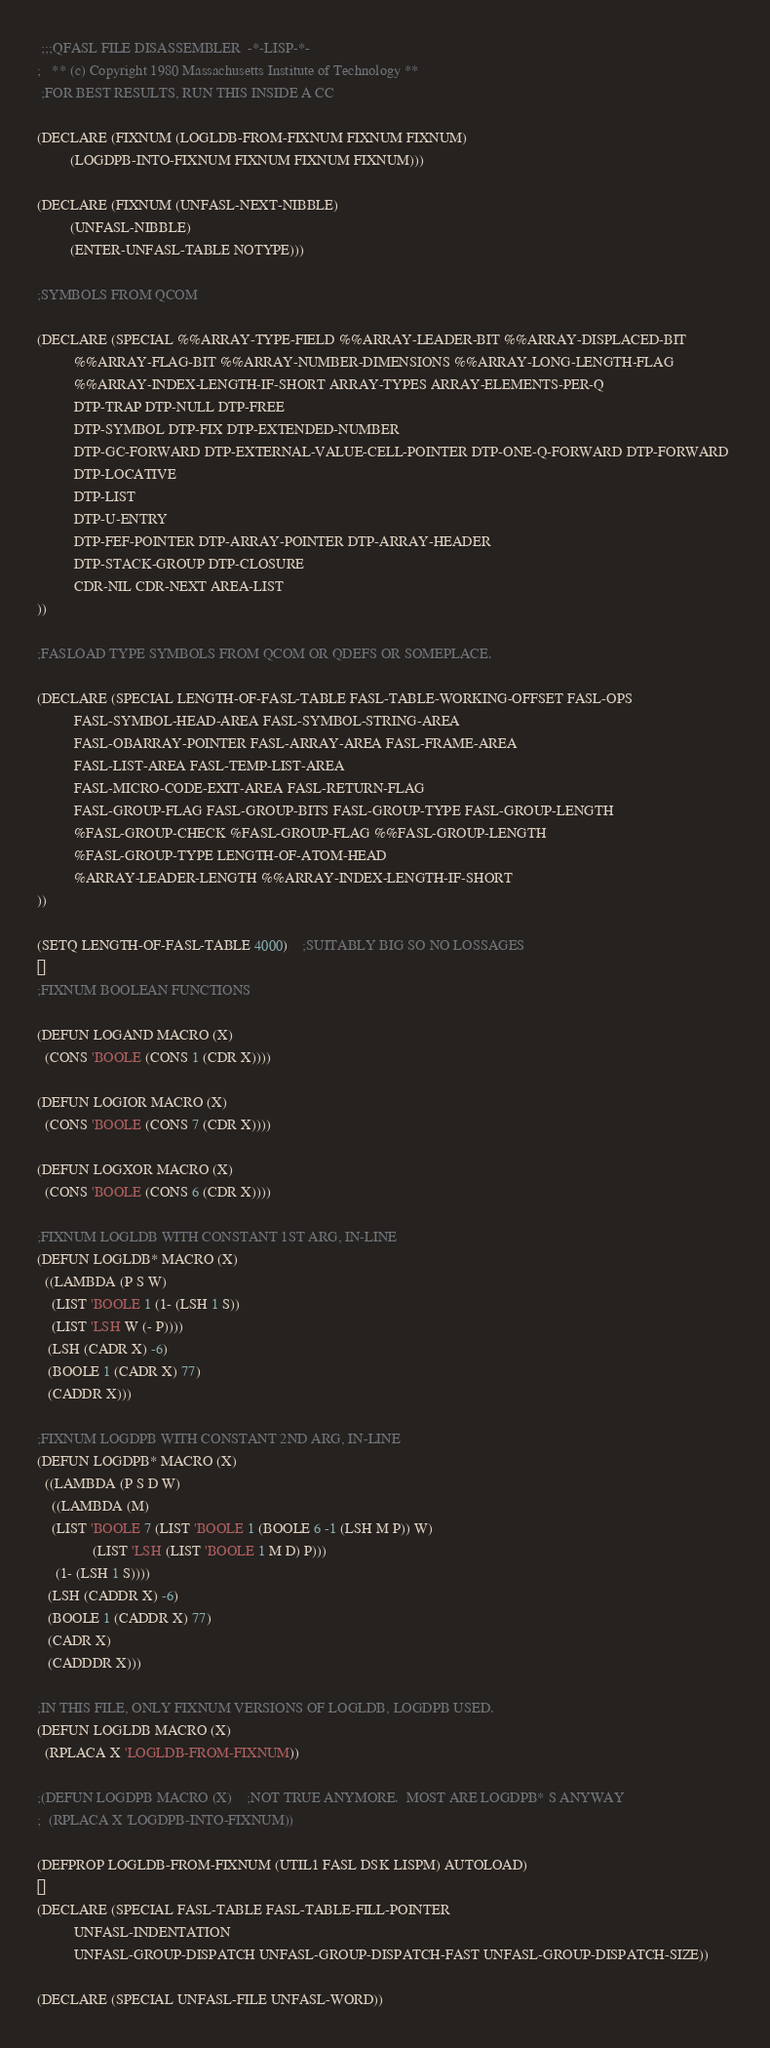<code> <loc_0><loc_0><loc_500><loc_500><_Lisp_> ;;;QFASL FILE DISASSEMBLER  -*-LISP-*-
;	** (c) Copyright 1980 Massachusetts Institute of Technology **
 ;FOR BEST RESULTS, RUN THIS INSIDE A CC

(DECLARE (FIXNUM (LOGLDB-FROM-FIXNUM FIXNUM FIXNUM)
		 (LOGDPB-INTO-FIXNUM FIXNUM FIXNUM FIXNUM)))

(DECLARE (FIXNUM (UNFASL-NEXT-NIBBLE)
		 (UNFASL-NIBBLE)
		 (ENTER-UNFASL-TABLE NOTYPE)))

;SYMBOLS FROM QCOM

(DECLARE (SPECIAL %%ARRAY-TYPE-FIELD %%ARRAY-LEADER-BIT %%ARRAY-DISPLACED-BIT
		  %%ARRAY-FLAG-BIT %%ARRAY-NUMBER-DIMENSIONS %%ARRAY-LONG-LENGTH-FLAG
		  %%ARRAY-INDEX-LENGTH-IF-SHORT ARRAY-TYPES ARRAY-ELEMENTS-PER-Q
		  DTP-TRAP DTP-NULL DTP-FREE 
		  DTP-SYMBOL DTP-FIX DTP-EXTENDED-NUMBER 
		  DTP-GC-FORWARD DTP-EXTERNAL-VALUE-CELL-POINTER DTP-ONE-Q-FORWARD DTP-FORWARD 
		  DTP-LOCATIVE  
		  DTP-LIST  
		  DTP-U-ENTRY  
		  DTP-FEF-POINTER DTP-ARRAY-POINTER DTP-ARRAY-HEADER 
		  DTP-STACK-GROUP DTP-CLOSURE
		  CDR-NIL CDR-NEXT AREA-LIST
))

;FASLOAD TYPE SYMBOLS FROM QCOM OR QDEFS OR SOMEPLACE.

(DECLARE (SPECIAL LENGTH-OF-FASL-TABLE FASL-TABLE-WORKING-OFFSET FASL-OPS
		  FASL-SYMBOL-HEAD-AREA FASL-SYMBOL-STRING-AREA
		  FASL-OBARRAY-POINTER FASL-ARRAY-AREA FASL-FRAME-AREA
		  FASL-LIST-AREA FASL-TEMP-LIST-AREA 
		  FASL-MICRO-CODE-EXIT-AREA FASL-RETURN-FLAG
		  FASL-GROUP-FLAG FASL-GROUP-BITS FASL-GROUP-TYPE FASL-GROUP-LENGTH
		  %FASL-GROUP-CHECK %FASL-GROUP-FLAG %%FASL-GROUP-LENGTH
		  %FASL-GROUP-TYPE LENGTH-OF-ATOM-HEAD
		  %ARRAY-LEADER-LENGTH %%ARRAY-INDEX-LENGTH-IF-SHORT
))

(SETQ LENGTH-OF-FASL-TABLE 4000)	;SUITABLY BIG SO NO LOSSAGES

;FIXNUM BOOLEAN FUNCTIONS

(DEFUN LOGAND MACRO (X)
  (CONS 'BOOLE (CONS 1 (CDR X))))

(DEFUN LOGIOR MACRO (X)
  (CONS 'BOOLE (CONS 7 (CDR X))))

(DEFUN LOGXOR MACRO (X)
  (CONS 'BOOLE (CONS 6 (CDR X))))

;FIXNUM LOGLDB WITH CONSTANT 1ST ARG, IN-LINE
(DEFUN LOGLDB* MACRO (X)
  ((LAMBDA (P S W)
    (LIST 'BOOLE 1 (1- (LSH 1 S))
	(LIST 'LSH W (- P))))
   (LSH (CADR X) -6)
   (BOOLE 1 (CADR X) 77)
   (CADDR X)))

;FIXNUM LOGDPB WITH CONSTANT 2ND ARG, IN-LINE
(DEFUN LOGDPB* MACRO (X)
  ((LAMBDA (P S D W)
    ((LAMBDA (M)
	(LIST 'BOOLE 7 (LIST 'BOOLE 1 (BOOLE 6 -1 (LSH M P)) W)
		       (LIST 'LSH (LIST 'BOOLE 1 M D) P)))
     (1- (LSH 1 S))))
   (LSH (CADDR X) -6)
   (BOOLE 1 (CADDR X) 77)
   (CADR X)
   (CADDDR X)))

;IN THIS FILE, ONLY FIXNUM VERSIONS OF LOGLDB, LOGDPB USED.
(DEFUN LOGLDB MACRO (X)
  (RPLACA X 'LOGLDB-FROM-FIXNUM))

;(DEFUN LOGDPB MACRO (X)	;NOT TRUE ANYMORE.  MOST ARE LOGDPB* S ANYWAY
;  (RPLACA X 'LOGDPB-INTO-FIXNUM))

(DEFPROP LOGLDB-FROM-FIXNUM (UTIL1 FASL DSK LISPM) AUTOLOAD)

(DECLARE (SPECIAL FASL-TABLE FASL-TABLE-FILL-POINTER
		  UNFASL-INDENTATION
		  UNFASL-GROUP-DISPATCH UNFASL-GROUP-DISPATCH-FAST UNFASL-GROUP-DISPATCH-SIZE))

(DECLARE (SPECIAL UNFASL-FILE UNFASL-WORD)) </code> 